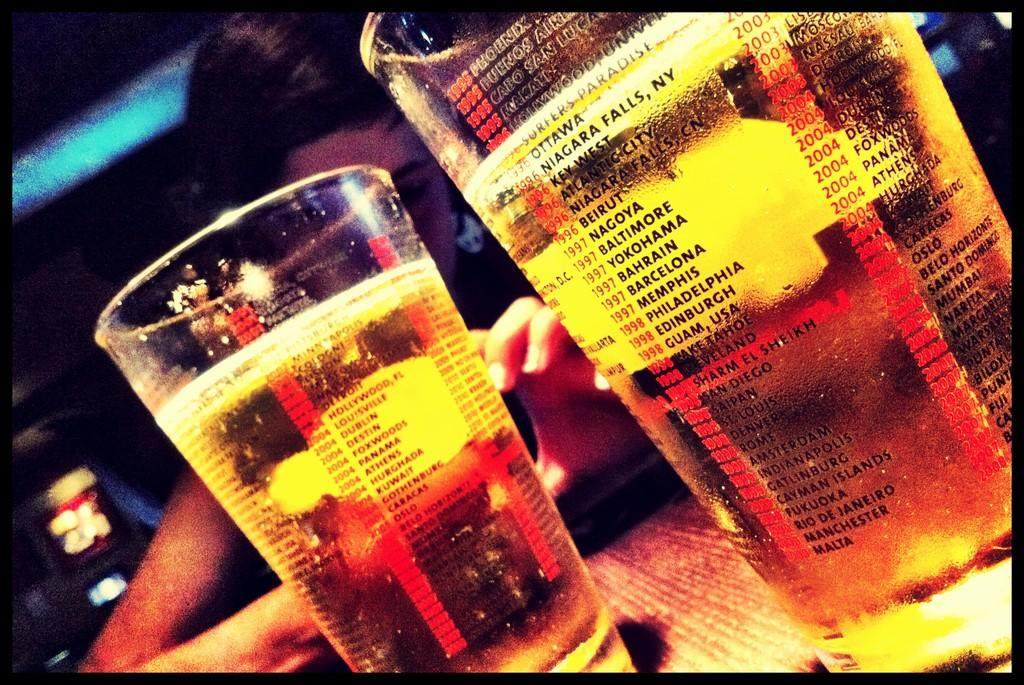<image>
Present a compact description of the photo's key features. the location of Yokohama written on the side of a glass 